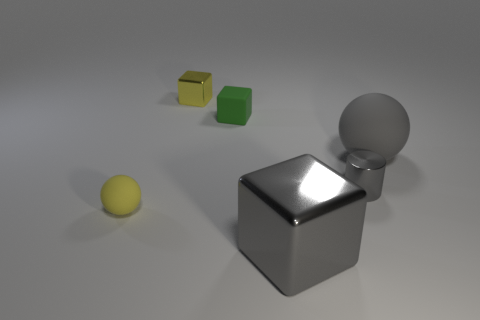Subtract all tiny cubes. How many cubes are left? 1 Add 1 yellow rubber spheres. How many objects exist? 7 Subtract all spheres. How many objects are left? 4 Subtract 0 red cylinders. How many objects are left? 6 Subtract all green rubber objects. Subtract all brown metal cylinders. How many objects are left? 5 Add 5 yellow objects. How many yellow objects are left? 7 Add 4 tiny cyan rubber cylinders. How many tiny cyan rubber cylinders exist? 4 